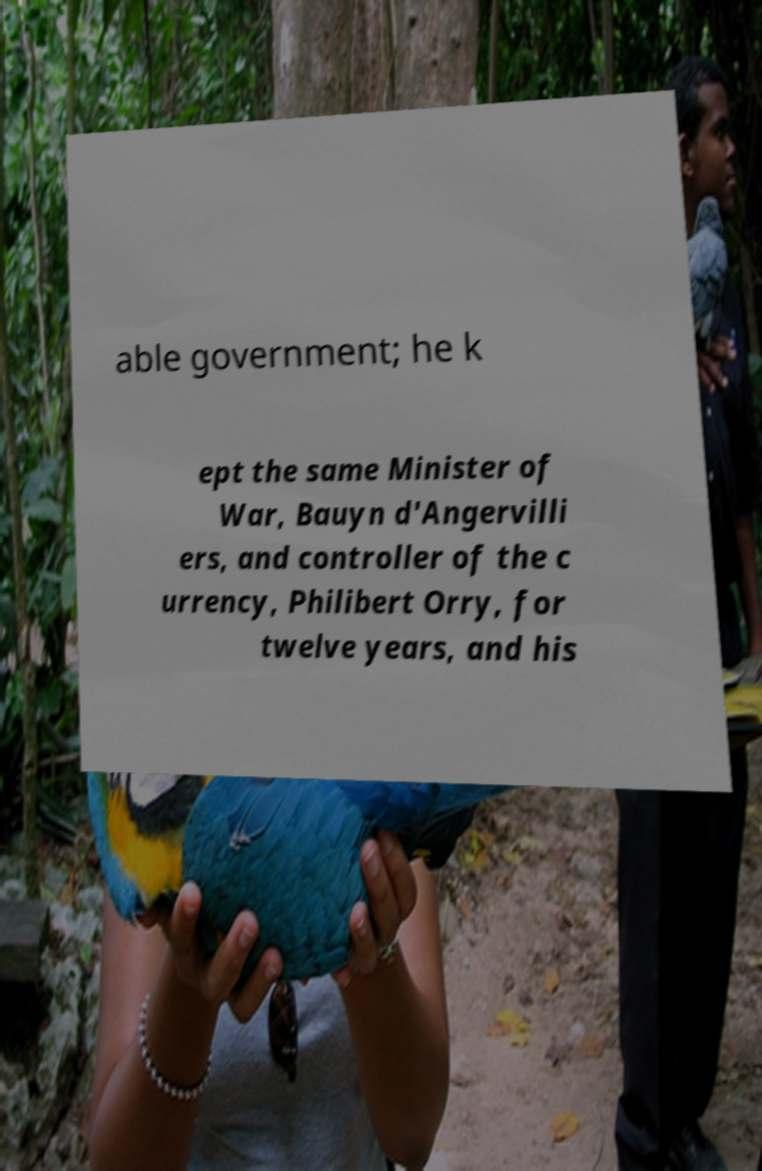Could you extract and type out the text from this image? able government; he k ept the same Minister of War, Bauyn d'Angervilli ers, and controller of the c urrency, Philibert Orry, for twelve years, and his 